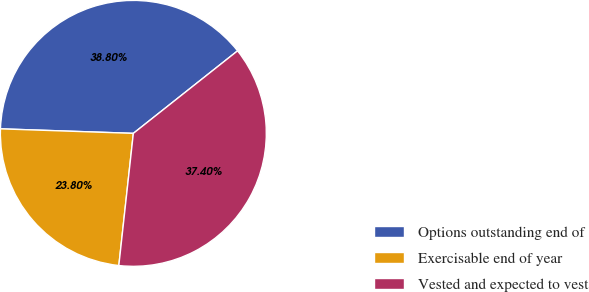Convert chart. <chart><loc_0><loc_0><loc_500><loc_500><pie_chart><fcel>Options outstanding end of<fcel>Exercisable end of year<fcel>Vested and expected to vest<nl><fcel>38.8%<fcel>23.8%<fcel>37.4%<nl></chart> 